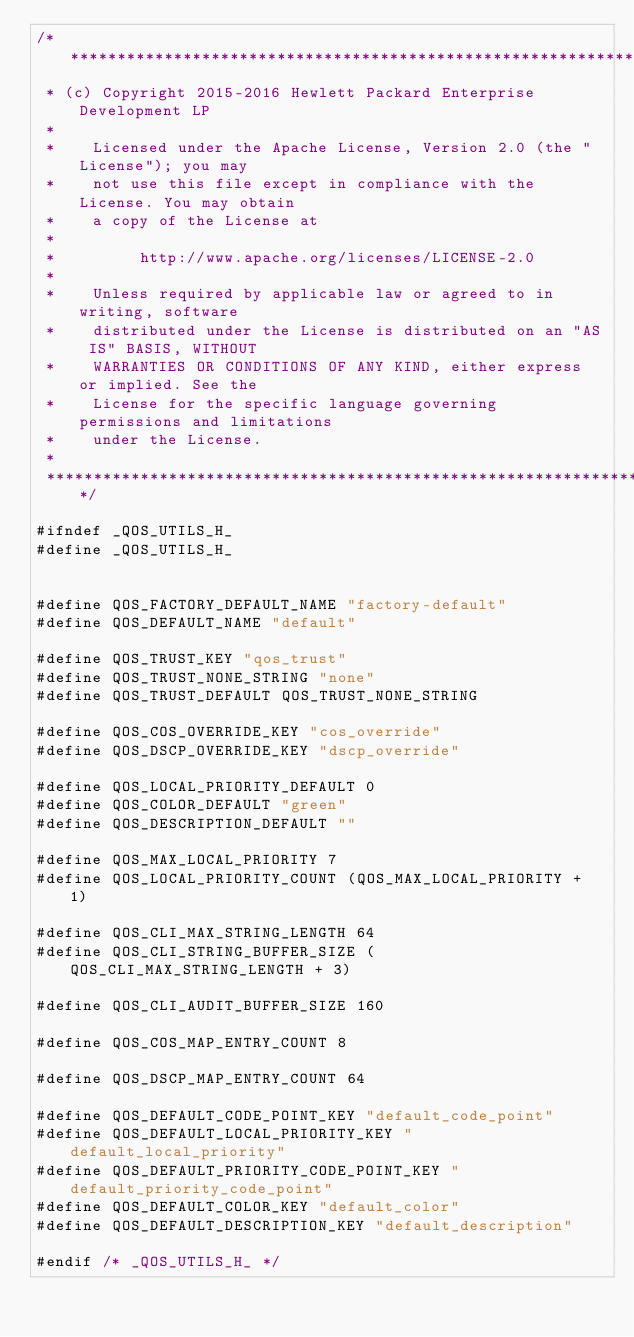Convert code to text. <code><loc_0><loc_0><loc_500><loc_500><_C_>/****************************************************************************
 * (c) Copyright 2015-2016 Hewlett Packard Enterprise Development LP
 *
 *    Licensed under the Apache License, Version 2.0 (the "License"); you may
 *    not use this file except in compliance with the License. You may obtain
 *    a copy of the License at
 *
 *         http://www.apache.org/licenses/LICENSE-2.0
 *
 *    Unless required by applicable law or agreed to in writing, software
 *    distributed under the License is distributed on an "AS IS" BASIS, WITHOUT
 *    WARRANTIES OR CONDITIONS OF ANY KIND, either express or implied. See the
 *    License for the specific language governing permissions and limitations
 *    under the License.
 *
 ***************************************************************************/

#ifndef _QOS_UTILS_H_
#define _QOS_UTILS_H_


#define QOS_FACTORY_DEFAULT_NAME "factory-default"
#define QOS_DEFAULT_NAME "default"

#define QOS_TRUST_KEY "qos_trust"
#define QOS_TRUST_NONE_STRING "none"
#define QOS_TRUST_DEFAULT QOS_TRUST_NONE_STRING

#define QOS_COS_OVERRIDE_KEY "cos_override"
#define QOS_DSCP_OVERRIDE_KEY "dscp_override"

#define QOS_LOCAL_PRIORITY_DEFAULT 0
#define QOS_COLOR_DEFAULT "green"
#define QOS_DESCRIPTION_DEFAULT ""

#define QOS_MAX_LOCAL_PRIORITY 7
#define QOS_LOCAL_PRIORITY_COUNT (QOS_MAX_LOCAL_PRIORITY + 1)

#define QOS_CLI_MAX_STRING_LENGTH 64
#define QOS_CLI_STRING_BUFFER_SIZE (QOS_CLI_MAX_STRING_LENGTH + 3)

#define QOS_CLI_AUDIT_BUFFER_SIZE 160

#define QOS_COS_MAP_ENTRY_COUNT 8

#define QOS_DSCP_MAP_ENTRY_COUNT 64

#define QOS_DEFAULT_CODE_POINT_KEY "default_code_point"
#define QOS_DEFAULT_LOCAL_PRIORITY_KEY "default_local_priority"
#define QOS_DEFAULT_PRIORITY_CODE_POINT_KEY "default_priority_code_point"
#define QOS_DEFAULT_COLOR_KEY "default_color"
#define QOS_DEFAULT_DESCRIPTION_KEY "default_description"

#endif /* _QOS_UTILS_H_ */
</code> 